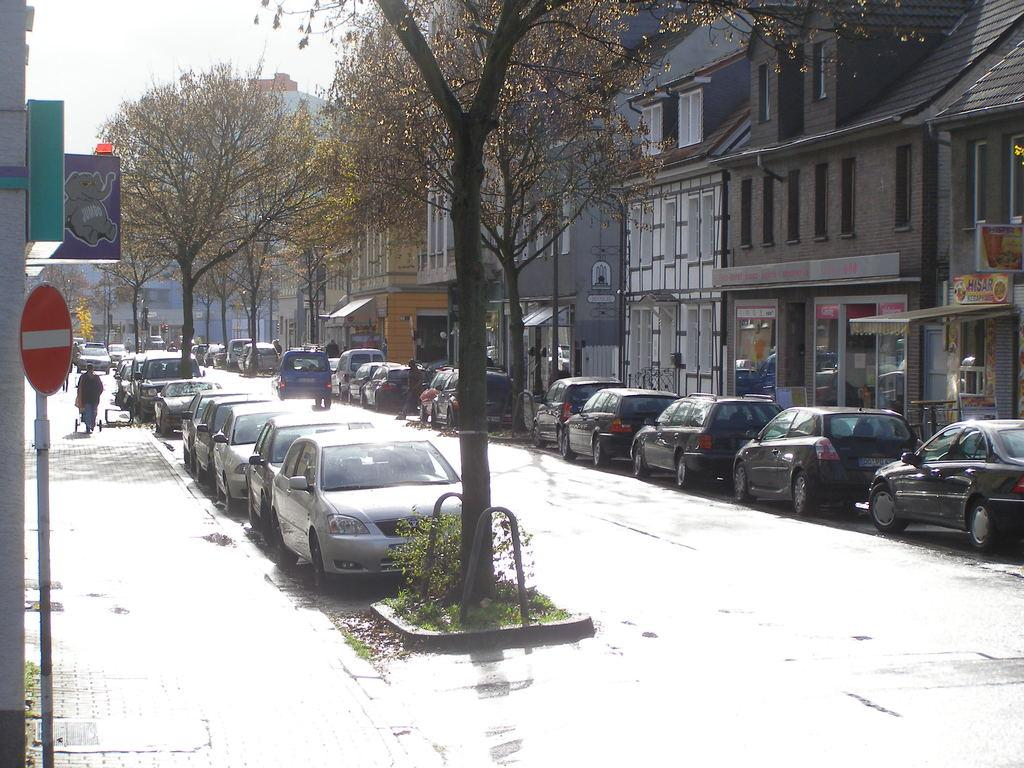What can be seen on the road in the image? There are many cars parked on the road in the image. What is visible at the bottom of the image? The road is visible at the bottom of the image. What is located to the right of the image? There are buildings to the right of the image. What type of vegetation is in the middle of the image? There are trees in the middle of the image. What is visible at the top of the image? The sky is visible at the top of the image. Where is the soap located in the image? There is no soap present in the image. What type of chairs can be seen in the meeting in the image? There is no meeting or chairs present in the image. 